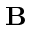Convert formula to latex. <formula><loc_0><loc_0><loc_500><loc_500>B</formula> 